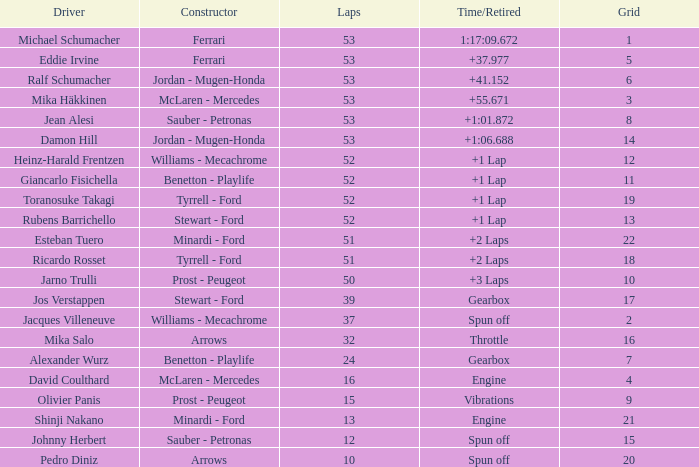What is the grid total for ralf schumacher racing over 53 laps? None. 